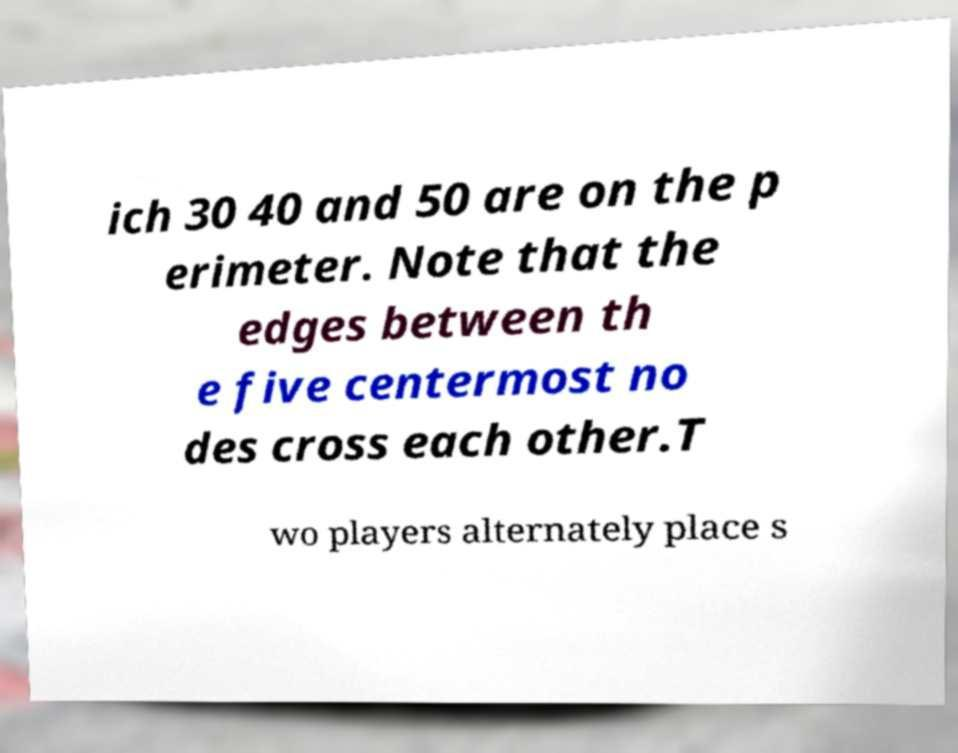I need the written content from this picture converted into text. Can you do that? ich 30 40 and 50 are on the p erimeter. Note that the edges between th e five centermost no des cross each other.T wo players alternately place s 